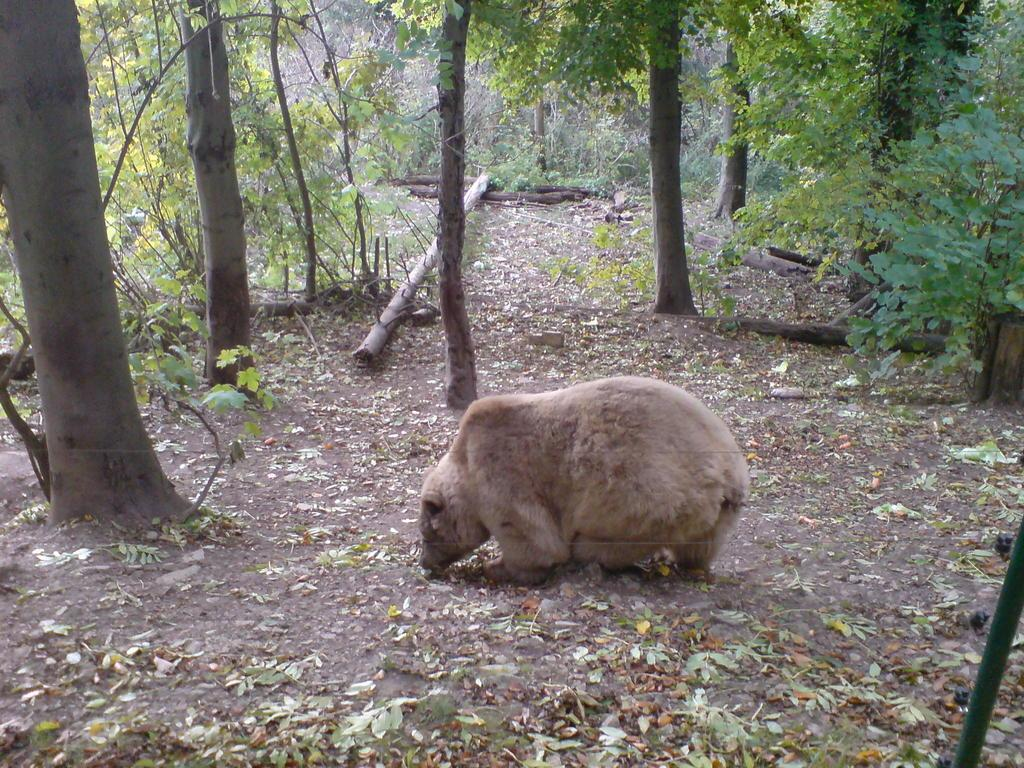What is present in the foreground of the picture? There are leaves, a dry leaves tree, and a brown bear in the foreground of the picture. What can be seen in the center of the picture? There are trees, plants, and wooden logs in the center of the picture. What type of alarm is the squirrel using to wake up the bear in the picture? There is no squirrel or alarm present in the image. How many pizzas are being served to the bear in the picture? There are no pizzas present in the image. 